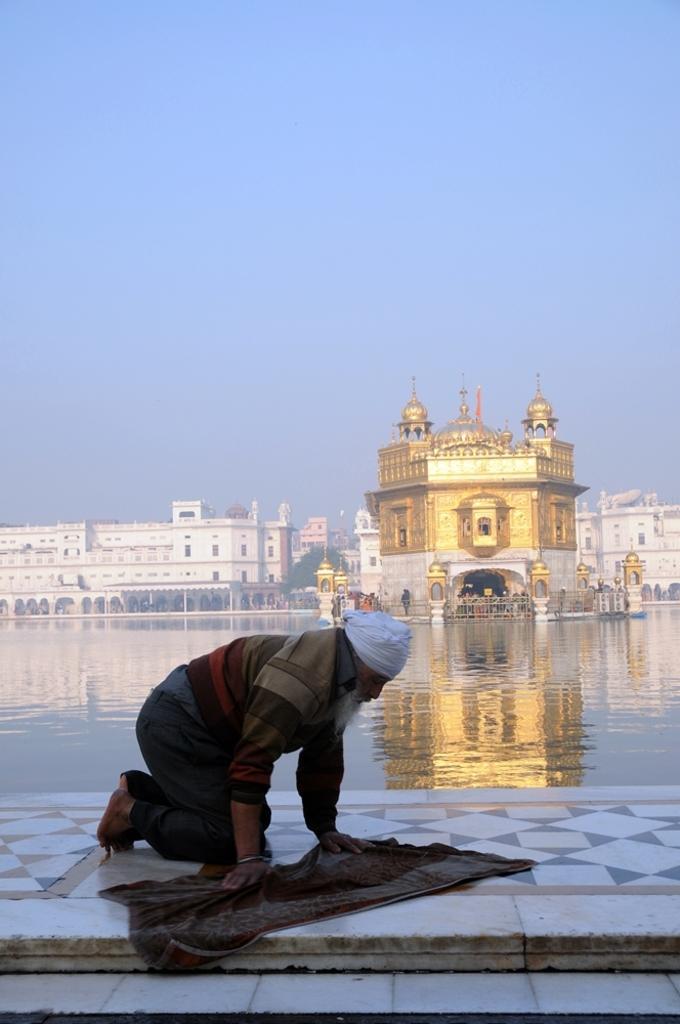Please provide a concise description of this image. In this given image, We can see a small lake and a person in kneeling position after that, We can see a temple, buildings, few trees next, We can see a mat, floor. 